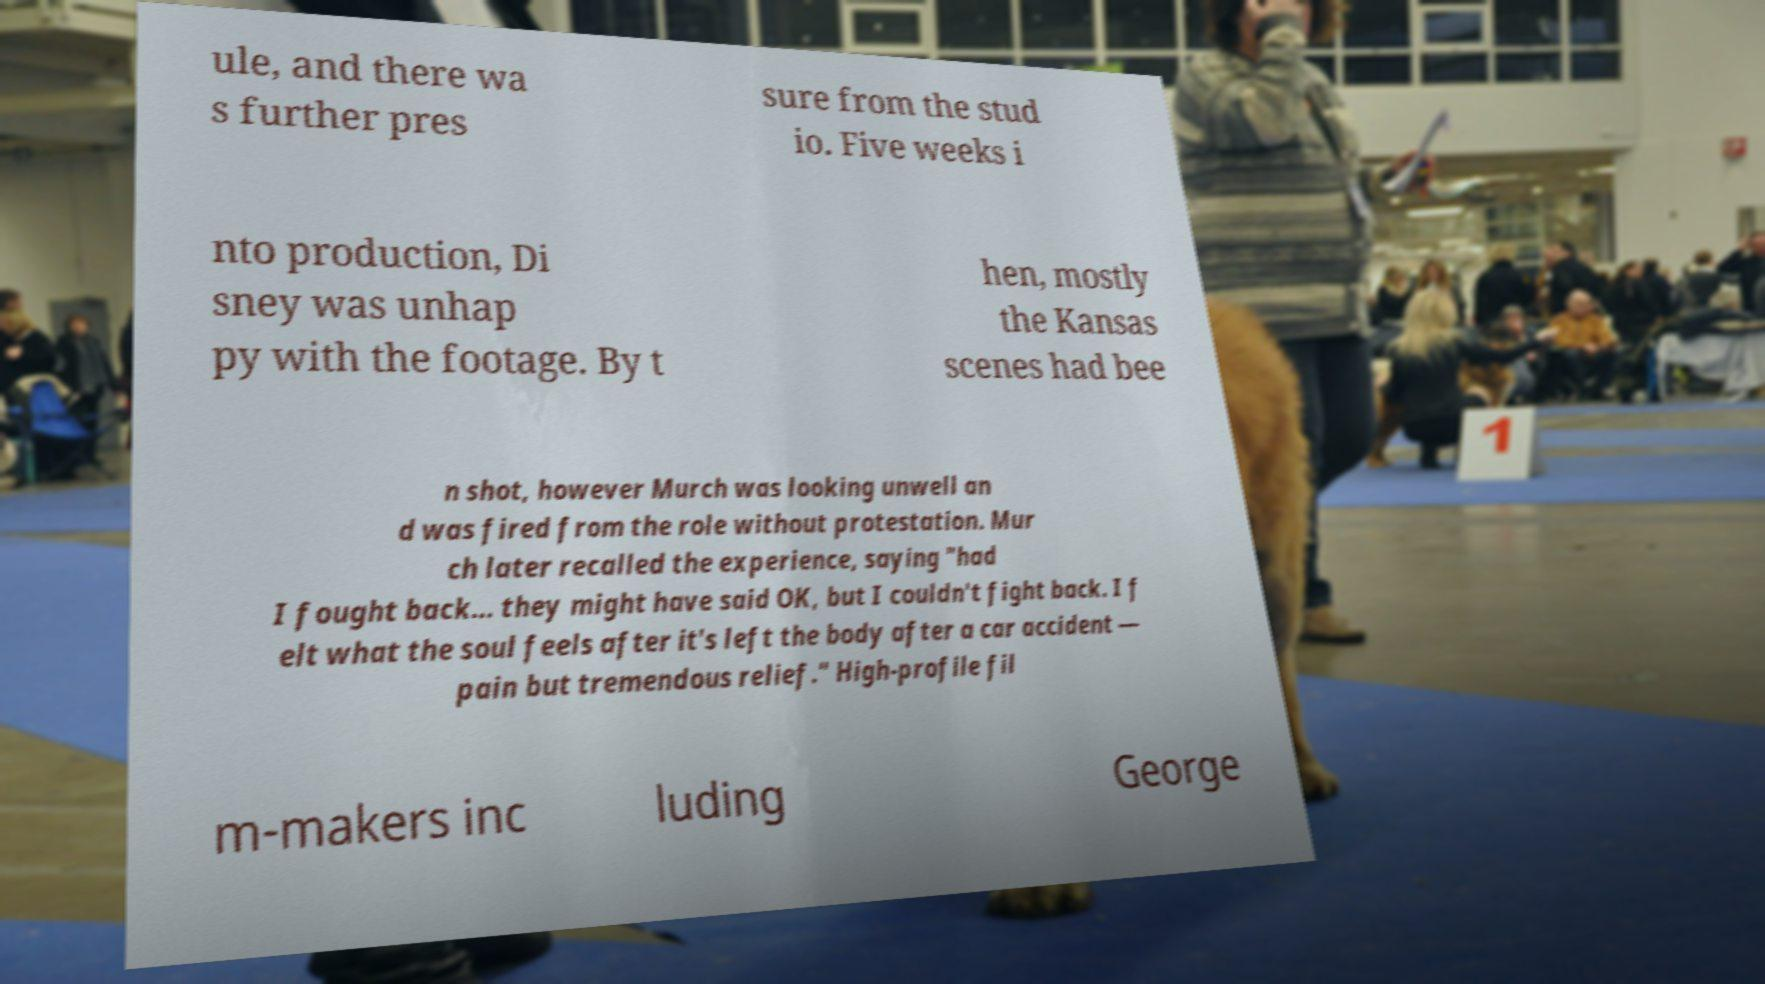I need the written content from this picture converted into text. Can you do that? ule, and there wa s further pres sure from the stud io. Five weeks i nto production, Di sney was unhap py with the footage. By t hen, mostly the Kansas scenes had bee n shot, however Murch was looking unwell an d was fired from the role without protestation. Mur ch later recalled the experience, saying "had I fought back... they might have said OK, but I couldn't fight back. I f elt what the soul feels after it's left the body after a car accident — pain but tremendous relief." High-profile fil m-makers inc luding George 